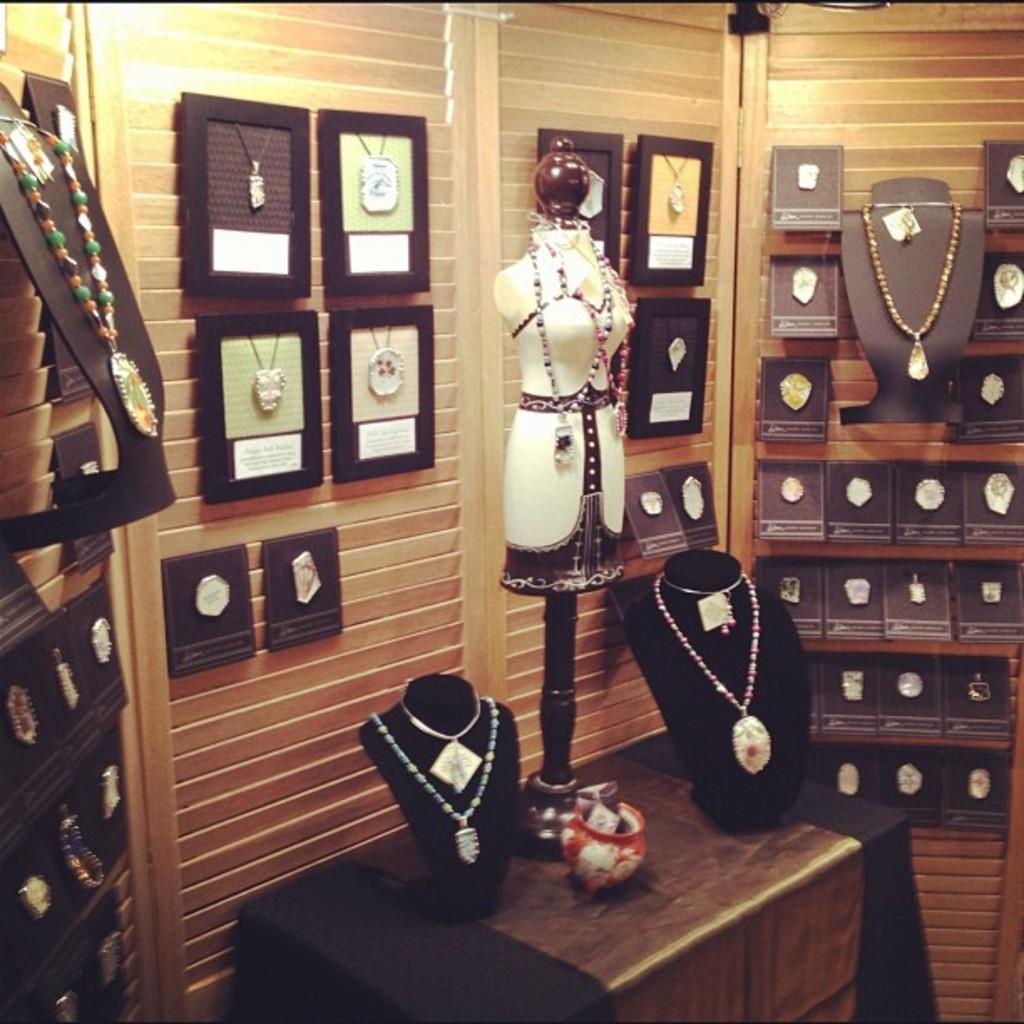In one or two sentences, can you explain what this image depicts? In this image I can see the mannequins with chains on the table. In the background I can see few more chains with frames and boxes. These are attached to the wooden object. 